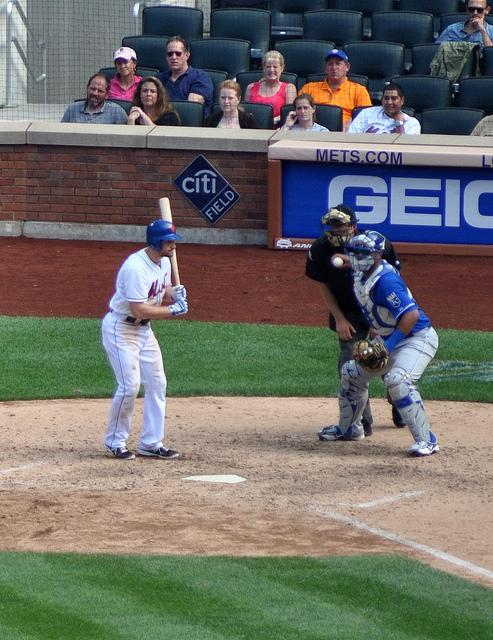Whose home field stadium is this? Please explain your reasoning. mets. You can see on their shirt they are with the mets 